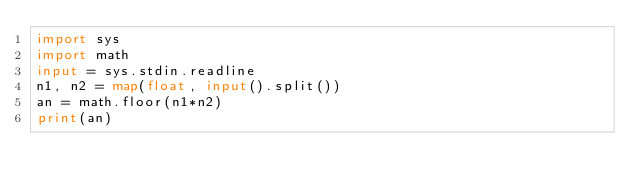<code> <loc_0><loc_0><loc_500><loc_500><_Python_>import sys
import math
input = sys.stdin.readline
n1, n2 = map(float, input().split())
an = math.floor(n1*n2)
print(an)</code> 